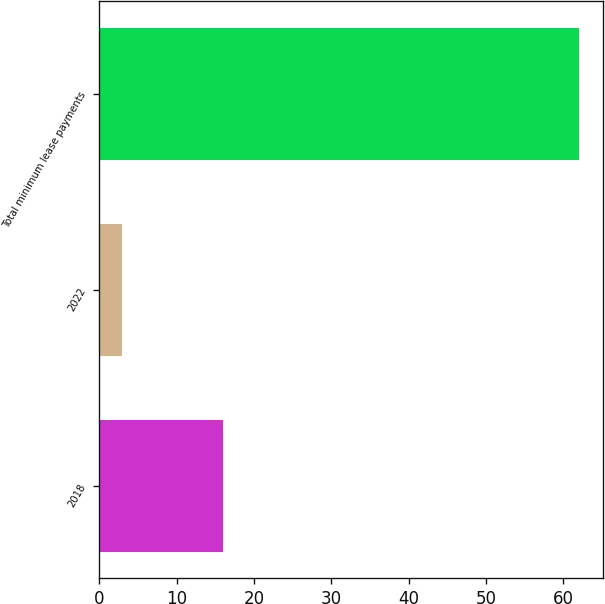Convert chart. <chart><loc_0><loc_0><loc_500><loc_500><bar_chart><fcel>2018<fcel>2022<fcel>Total minimum lease payments<nl><fcel>16<fcel>3<fcel>62<nl></chart> 